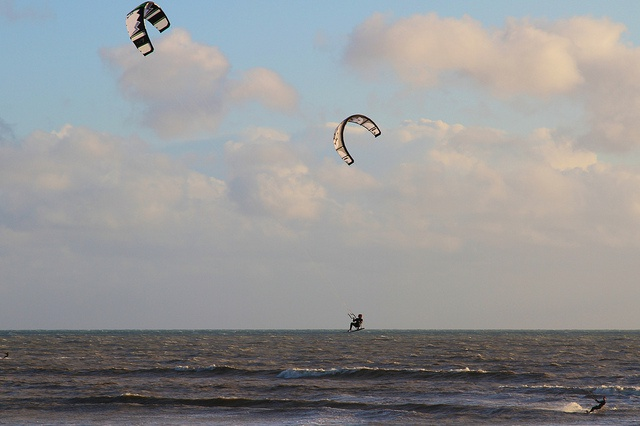Describe the objects in this image and their specific colors. I can see kite in darkgray, black, tan, and gray tones, kite in darkgray, black, tan, and gray tones, people in darkgray, black, gray, and maroon tones, people in darkgray, black, gray, maroon, and brown tones, and surfboard in darkgray, black, and gray tones in this image. 